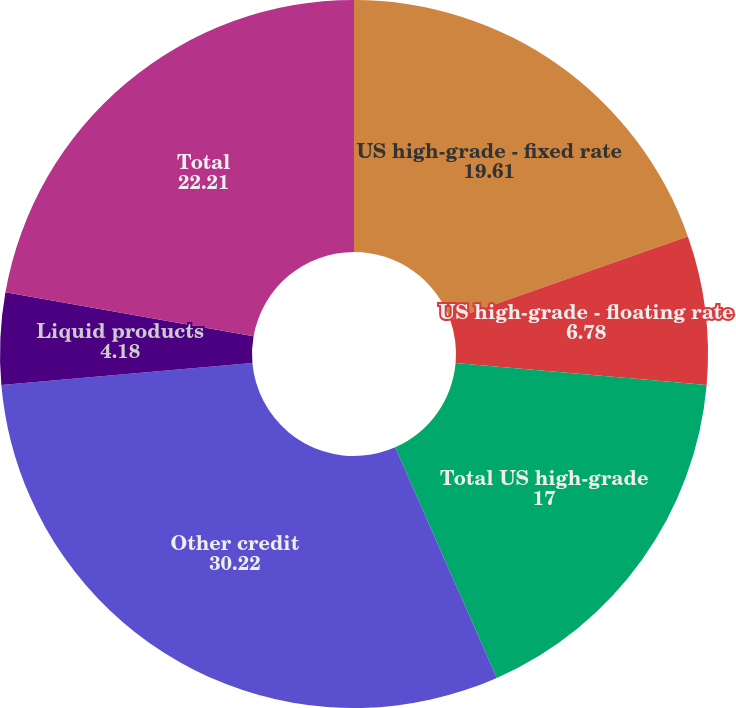<chart> <loc_0><loc_0><loc_500><loc_500><pie_chart><fcel>US high-grade - fixed rate<fcel>US high-grade - floating rate<fcel>Total US high-grade<fcel>Other credit<fcel>Liquid products<fcel>Total<nl><fcel>19.61%<fcel>6.78%<fcel>17.0%<fcel>30.22%<fcel>4.18%<fcel>22.21%<nl></chart> 